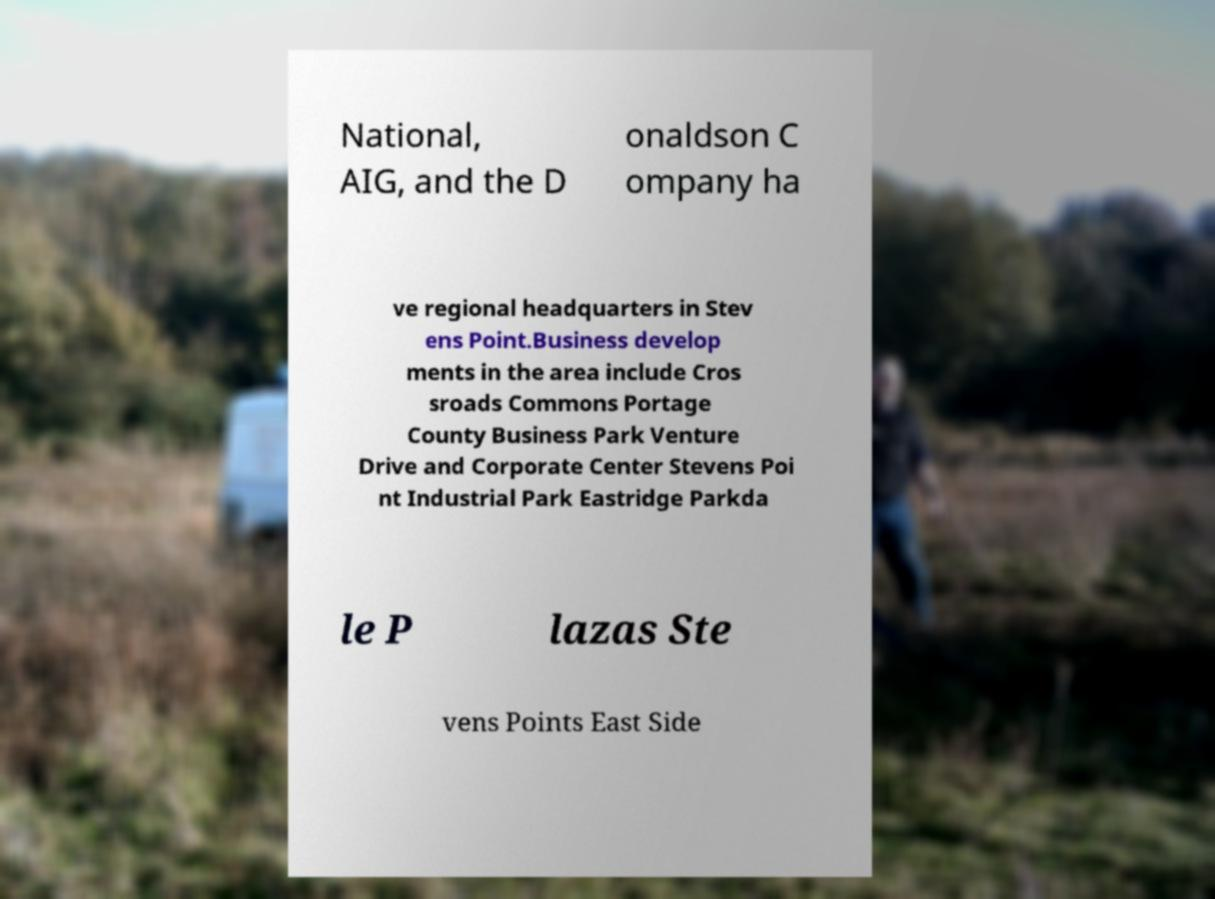There's text embedded in this image that I need extracted. Can you transcribe it verbatim? National, AIG, and the D onaldson C ompany ha ve regional headquarters in Stev ens Point.Business develop ments in the area include Cros sroads Commons Portage County Business Park Venture Drive and Corporate Center Stevens Poi nt Industrial Park Eastridge Parkda le P lazas Ste vens Points East Side 